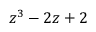Convert formula to latex. <formula><loc_0><loc_0><loc_500><loc_500>z ^ { 3 } - 2 z + 2</formula> 